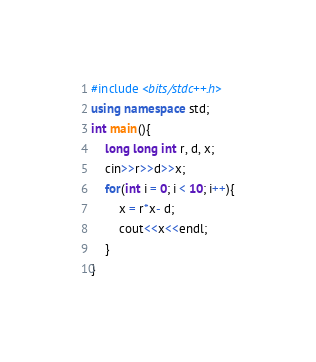<code> <loc_0><loc_0><loc_500><loc_500><_C++_>#include <bits/stdc++.h> 
using namespace std;
int main(){
    long long int r, d, x;
    cin>>r>>d>>x;
    for(int i = 0; i < 10; i++){
        x = r*x- d;
        cout<<x<<endl;
    }
}</code> 